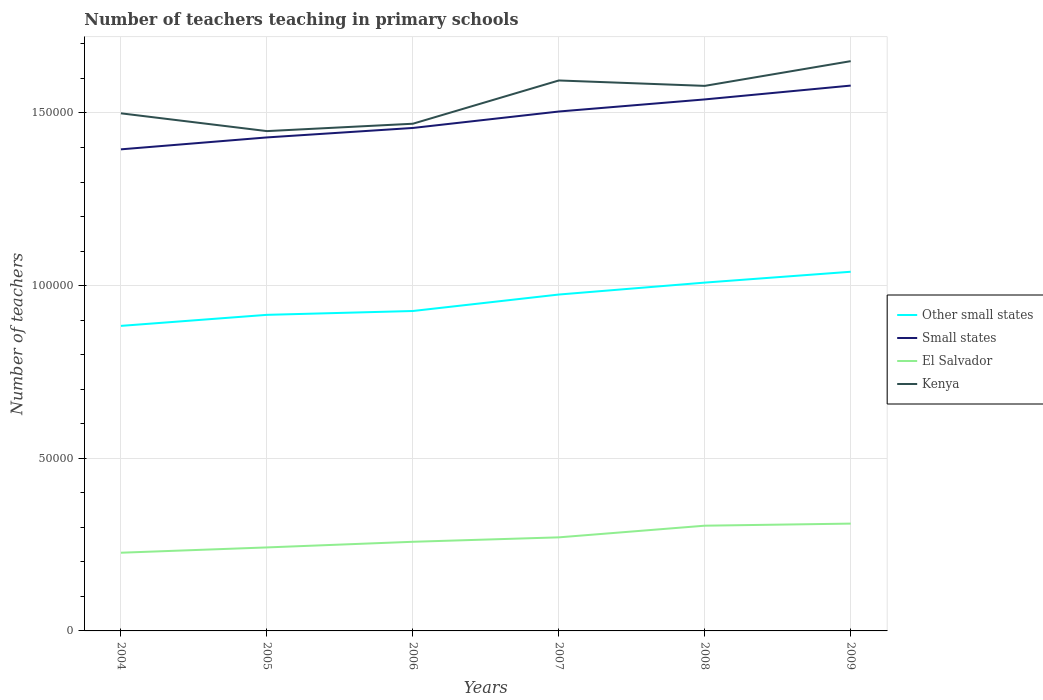Does the line corresponding to El Salvador intersect with the line corresponding to Other small states?
Offer a terse response. No. Across all years, what is the maximum number of teachers teaching in primary schools in Small states?
Provide a succinct answer. 1.39e+05. What is the total number of teachers teaching in primary schools in El Salvador in the graph?
Offer a very short reply. -8428. What is the difference between the highest and the second highest number of teachers teaching in primary schools in El Salvador?
Your response must be concise. 8428. How many lines are there?
Provide a succinct answer. 4. Are the values on the major ticks of Y-axis written in scientific E-notation?
Your answer should be very brief. No. Does the graph contain any zero values?
Offer a very short reply. No. Where does the legend appear in the graph?
Your answer should be compact. Center right. How many legend labels are there?
Give a very brief answer. 4. What is the title of the graph?
Provide a succinct answer. Number of teachers teaching in primary schools. Does "Greenland" appear as one of the legend labels in the graph?
Your answer should be compact. No. What is the label or title of the X-axis?
Keep it short and to the point. Years. What is the label or title of the Y-axis?
Offer a terse response. Number of teachers. What is the Number of teachers in Other small states in 2004?
Offer a terse response. 8.83e+04. What is the Number of teachers of Small states in 2004?
Provide a short and direct response. 1.39e+05. What is the Number of teachers of El Salvador in 2004?
Your response must be concise. 2.26e+04. What is the Number of teachers in Kenya in 2004?
Provide a succinct answer. 1.50e+05. What is the Number of teachers in Other small states in 2005?
Your answer should be very brief. 9.15e+04. What is the Number of teachers of Small states in 2005?
Give a very brief answer. 1.43e+05. What is the Number of teachers in El Salvador in 2005?
Give a very brief answer. 2.42e+04. What is the Number of teachers of Kenya in 2005?
Your answer should be very brief. 1.45e+05. What is the Number of teachers of Other small states in 2006?
Keep it short and to the point. 9.26e+04. What is the Number of teachers in Small states in 2006?
Offer a terse response. 1.46e+05. What is the Number of teachers of El Salvador in 2006?
Your answer should be very brief. 2.58e+04. What is the Number of teachers of Kenya in 2006?
Provide a succinct answer. 1.47e+05. What is the Number of teachers of Other small states in 2007?
Provide a succinct answer. 9.74e+04. What is the Number of teachers of Small states in 2007?
Keep it short and to the point. 1.50e+05. What is the Number of teachers in El Salvador in 2007?
Offer a very short reply. 2.71e+04. What is the Number of teachers in Kenya in 2007?
Provide a short and direct response. 1.59e+05. What is the Number of teachers of Other small states in 2008?
Provide a succinct answer. 1.01e+05. What is the Number of teachers of Small states in 2008?
Your response must be concise. 1.54e+05. What is the Number of teachers in El Salvador in 2008?
Offer a very short reply. 3.05e+04. What is the Number of teachers of Kenya in 2008?
Give a very brief answer. 1.58e+05. What is the Number of teachers of Other small states in 2009?
Give a very brief answer. 1.04e+05. What is the Number of teachers of Small states in 2009?
Your answer should be very brief. 1.58e+05. What is the Number of teachers in El Salvador in 2009?
Keep it short and to the point. 3.11e+04. What is the Number of teachers of Kenya in 2009?
Keep it short and to the point. 1.65e+05. Across all years, what is the maximum Number of teachers of Other small states?
Give a very brief answer. 1.04e+05. Across all years, what is the maximum Number of teachers in Small states?
Your response must be concise. 1.58e+05. Across all years, what is the maximum Number of teachers of El Salvador?
Offer a terse response. 3.11e+04. Across all years, what is the maximum Number of teachers in Kenya?
Make the answer very short. 1.65e+05. Across all years, what is the minimum Number of teachers in Other small states?
Keep it short and to the point. 8.83e+04. Across all years, what is the minimum Number of teachers in Small states?
Give a very brief answer. 1.39e+05. Across all years, what is the minimum Number of teachers in El Salvador?
Offer a very short reply. 2.26e+04. Across all years, what is the minimum Number of teachers in Kenya?
Offer a very short reply. 1.45e+05. What is the total Number of teachers in Other small states in the graph?
Your answer should be compact. 5.75e+05. What is the total Number of teachers of Small states in the graph?
Ensure brevity in your answer.  8.90e+05. What is the total Number of teachers in El Salvador in the graph?
Your answer should be very brief. 1.61e+05. What is the total Number of teachers in Kenya in the graph?
Provide a succinct answer. 9.24e+05. What is the difference between the Number of teachers of Other small states in 2004 and that in 2005?
Ensure brevity in your answer.  -3195.5. What is the difference between the Number of teachers in Small states in 2004 and that in 2005?
Your response must be concise. -3449.75. What is the difference between the Number of teachers of El Salvador in 2004 and that in 2005?
Give a very brief answer. -1530. What is the difference between the Number of teachers in Kenya in 2004 and that in 2005?
Offer a terse response. 5149. What is the difference between the Number of teachers in Other small states in 2004 and that in 2006?
Your response must be concise. -4307.96. What is the difference between the Number of teachers in Small states in 2004 and that in 2006?
Make the answer very short. -6191.81. What is the difference between the Number of teachers in El Salvador in 2004 and that in 2006?
Your response must be concise. -3164. What is the difference between the Number of teachers in Kenya in 2004 and that in 2006?
Your answer should be compact. 3014. What is the difference between the Number of teachers of Other small states in 2004 and that in 2007?
Offer a terse response. -9074.27. What is the difference between the Number of teachers of Small states in 2004 and that in 2007?
Give a very brief answer. -1.10e+04. What is the difference between the Number of teachers in El Salvador in 2004 and that in 2007?
Your answer should be compact. -4449. What is the difference between the Number of teachers in Kenya in 2004 and that in 2007?
Offer a terse response. -9514. What is the difference between the Number of teachers in Other small states in 2004 and that in 2008?
Your answer should be compact. -1.25e+04. What is the difference between the Number of teachers in Small states in 2004 and that in 2008?
Give a very brief answer. -1.45e+04. What is the difference between the Number of teachers of El Salvador in 2004 and that in 2008?
Keep it short and to the point. -7825. What is the difference between the Number of teachers of Kenya in 2004 and that in 2008?
Offer a very short reply. -7950. What is the difference between the Number of teachers of Other small states in 2004 and that in 2009?
Your response must be concise. -1.57e+04. What is the difference between the Number of teachers of Small states in 2004 and that in 2009?
Provide a succinct answer. -1.85e+04. What is the difference between the Number of teachers in El Salvador in 2004 and that in 2009?
Ensure brevity in your answer.  -8428. What is the difference between the Number of teachers of Kenya in 2004 and that in 2009?
Give a very brief answer. -1.51e+04. What is the difference between the Number of teachers of Other small states in 2005 and that in 2006?
Your response must be concise. -1112.46. What is the difference between the Number of teachers of Small states in 2005 and that in 2006?
Provide a succinct answer. -2742.06. What is the difference between the Number of teachers of El Salvador in 2005 and that in 2006?
Offer a very short reply. -1634. What is the difference between the Number of teachers of Kenya in 2005 and that in 2006?
Your response must be concise. -2135. What is the difference between the Number of teachers in Other small states in 2005 and that in 2007?
Make the answer very short. -5878.77. What is the difference between the Number of teachers in Small states in 2005 and that in 2007?
Ensure brevity in your answer.  -7502.22. What is the difference between the Number of teachers of El Salvador in 2005 and that in 2007?
Give a very brief answer. -2919. What is the difference between the Number of teachers in Kenya in 2005 and that in 2007?
Keep it short and to the point. -1.47e+04. What is the difference between the Number of teachers in Other small states in 2005 and that in 2008?
Make the answer very short. -9336.92. What is the difference between the Number of teachers in Small states in 2005 and that in 2008?
Make the answer very short. -1.10e+04. What is the difference between the Number of teachers in El Salvador in 2005 and that in 2008?
Provide a short and direct response. -6295. What is the difference between the Number of teachers of Kenya in 2005 and that in 2008?
Give a very brief answer. -1.31e+04. What is the difference between the Number of teachers of Other small states in 2005 and that in 2009?
Keep it short and to the point. -1.25e+04. What is the difference between the Number of teachers in Small states in 2005 and that in 2009?
Provide a short and direct response. -1.50e+04. What is the difference between the Number of teachers of El Salvador in 2005 and that in 2009?
Offer a very short reply. -6898. What is the difference between the Number of teachers of Kenya in 2005 and that in 2009?
Offer a terse response. -2.03e+04. What is the difference between the Number of teachers in Other small states in 2006 and that in 2007?
Offer a very short reply. -4766.31. What is the difference between the Number of teachers in Small states in 2006 and that in 2007?
Offer a very short reply. -4760.16. What is the difference between the Number of teachers of El Salvador in 2006 and that in 2007?
Your answer should be compact. -1285. What is the difference between the Number of teachers of Kenya in 2006 and that in 2007?
Your response must be concise. -1.25e+04. What is the difference between the Number of teachers of Other small states in 2006 and that in 2008?
Provide a short and direct response. -8224.46. What is the difference between the Number of teachers in Small states in 2006 and that in 2008?
Provide a short and direct response. -8265.47. What is the difference between the Number of teachers in El Salvador in 2006 and that in 2008?
Keep it short and to the point. -4661. What is the difference between the Number of teachers in Kenya in 2006 and that in 2008?
Your answer should be very brief. -1.10e+04. What is the difference between the Number of teachers in Other small states in 2006 and that in 2009?
Provide a short and direct response. -1.14e+04. What is the difference between the Number of teachers of Small states in 2006 and that in 2009?
Your answer should be compact. -1.23e+04. What is the difference between the Number of teachers in El Salvador in 2006 and that in 2009?
Provide a succinct answer. -5264. What is the difference between the Number of teachers in Kenya in 2006 and that in 2009?
Ensure brevity in your answer.  -1.81e+04. What is the difference between the Number of teachers in Other small states in 2007 and that in 2008?
Offer a very short reply. -3458.15. What is the difference between the Number of teachers of Small states in 2007 and that in 2008?
Your response must be concise. -3505.31. What is the difference between the Number of teachers of El Salvador in 2007 and that in 2008?
Provide a short and direct response. -3376. What is the difference between the Number of teachers in Kenya in 2007 and that in 2008?
Ensure brevity in your answer.  1564. What is the difference between the Number of teachers in Other small states in 2007 and that in 2009?
Give a very brief answer. -6601.63. What is the difference between the Number of teachers of Small states in 2007 and that in 2009?
Give a very brief answer. -7508.78. What is the difference between the Number of teachers of El Salvador in 2007 and that in 2009?
Keep it short and to the point. -3979. What is the difference between the Number of teachers in Kenya in 2007 and that in 2009?
Keep it short and to the point. -5595. What is the difference between the Number of teachers in Other small states in 2008 and that in 2009?
Provide a short and direct response. -3143.48. What is the difference between the Number of teachers in Small states in 2008 and that in 2009?
Offer a very short reply. -4003.47. What is the difference between the Number of teachers of El Salvador in 2008 and that in 2009?
Your answer should be very brief. -603. What is the difference between the Number of teachers of Kenya in 2008 and that in 2009?
Your answer should be compact. -7159. What is the difference between the Number of teachers of Other small states in 2004 and the Number of teachers of Small states in 2005?
Make the answer very short. -5.46e+04. What is the difference between the Number of teachers of Other small states in 2004 and the Number of teachers of El Salvador in 2005?
Provide a short and direct response. 6.42e+04. What is the difference between the Number of teachers in Other small states in 2004 and the Number of teachers in Kenya in 2005?
Make the answer very short. -5.64e+04. What is the difference between the Number of teachers in Small states in 2004 and the Number of teachers in El Salvador in 2005?
Give a very brief answer. 1.15e+05. What is the difference between the Number of teachers of Small states in 2004 and the Number of teachers of Kenya in 2005?
Ensure brevity in your answer.  -5279.61. What is the difference between the Number of teachers of El Salvador in 2004 and the Number of teachers of Kenya in 2005?
Your answer should be very brief. -1.22e+05. What is the difference between the Number of teachers of Other small states in 2004 and the Number of teachers of Small states in 2006?
Provide a succinct answer. -5.73e+04. What is the difference between the Number of teachers of Other small states in 2004 and the Number of teachers of El Salvador in 2006?
Offer a very short reply. 6.25e+04. What is the difference between the Number of teachers of Other small states in 2004 and the Number of teachers of Kenya in 2006?
Offer a terse response. -5.85e+04. What is the difference between the Number of teachers in Small states in 2004 and the Number of teachers in El Salvador in 2006?
Provide a succinct answer. 1.14e+05. What is the difference between the Number of teachers of Small states in 2004 and the Number of teachers of Kenya in 2006?
Provide a short and direct response. -7414.61. What is the difference between the Number of teachers in El Salvador in 2004 and the Number of teachers in Kenya in 2006?
Provide a short and direct response. -1.24e+05. What is the difference between the Number of teachers in Other small states in 2004 and the Number of teachers in Small states in 2007?
Your answer should be very brief. -6.21e+04. What is the difference between the Number of teachers in Other small states in 2004 and the Number of teachers in El Salvador in 2007?
Your response must be concise. 6.12e+04. What is the difference between the Number of teachers of Other small states in 2004 and the Number of teachers of Kenya in 2007?
Your response must be concise. -7.11e+04. What is the difference between the Number of teachers in Small states in 2004 and the Number of teachers in El Salvador in 2007?
Your answer should be very brief. 1.12e+05. What is the difference between the Number of teachers of Small states in 2004 and the Number of teachers of Kenya in 2007?
Provide a succinct answer. -1.99e+04. What is the difference between the Number of teachers in El Salvador in 2004 and the Number of teachers in Kenya in 2007?
Offer a terse response. -1.37e+05. What is the difference between the Number of teachers in Other small states in 2004 and the Number of teachers in Small states in 2008?
Your response must be concise. -6.56e+04. What is the difference between the Number of teachers of Other small states in 2004 and the Number of teachers of El Salvador in 2008?
Your answer should be very brief. 5.79e+04. What is the difference between the Number of teachers in Other small states in 2004 and the Number of teachers in Kenya in 2008?
Offer a terse response. -6.95e+04. What is the difference between the Number of teachers of Small states in 2004 and the Number of teachers of El Salvador in 2008?
Give a very brief answer. 1.09e+05. What is the difference between the Number of teachers in Small states in 2004 and the Number of teachers in Kenya in 2008?
Provide a short and direct response. -1.84e+04. What is the difference between the Number of teachers in El Salvador in 2004 and the Number of teachers in Kenya in 2008?
Make the answer very short. -1.35e+05. What is the difference between the Number of teachers of Other small states in 2004 and the Number of teachers of Small states in 2009?
Your answer should be compact. -6.96e+04. What is the difference between the Number of teachers of Other small states in 2004 and the Number of teachers of El Salvador in 2009?
Give a very brief answer. 5.73e+04. What is the difference between the Number of teachers in Other small states in 2004 and the Number of teachers in Kenya in 2009?
Your answer should be compact. -7.67e+04. What is the difference between the Number of teachers of Small states in 2004 and the Number of teachers of El Salvador in 2009?
Offer a terse response. 1.08e+05. What is the difference between the Number of teachers of Small states in 2004 and the Number of teachers of Kenya in 2009?
Your answer should be very brief. -2.55e+04. What is the difference between the Number of teachers in El Salvador in 2004 and the Number of teachers in Kenya in 2009?
Offer a terse response. -1.42e+05. What is the difference between the Number of teachers in Other small states in 2005 and the Number of teachers in Small states in 2006?
Ensure brevity in your answer.  -5.41e+04. What is the difference between the Number of teachers of Other small states in 2005 and the Number of teachers of El Salvador in 2006?
Make the answer very short. 6.57e+04. What is the difference between the Number of teachers of Other small states in 2005 and the Number of teachers of Kenya in 2006?
Offer a terse response. -5.53e+04. What is the difference between the Number of teachers of Small states in 2005 and the Number of teachers of El Salvador in 2006?
Offer a very short reply. 1.17e+05. What is the difference between the Number of teachers of Small states in 2005 and the Number of teachers of Kenya in 2006?
Your answer should be very brief. -3964.86. What is the difference between the Number of teachers of El Salvador in 2005 and the Number of teachers of Kenya in 2006?
Offer a terse response. -1.23e+05. What is the difference between the Number of teachers in Other small states in 2005 and the Number of teachers in Small states in 2007?
Make the answer very short. -5.89e+04. What is the difference between the Number of teachers in Other small states in 2005 and the Number of teachers in El Salvador in 2007?
Your answer should be very brief. 6.44e+04. What is the difference between the Number of teachers of Other small states in 2005 and the Number of teachers of Kenya in 2007?
Your response must be concise. -6.79e+04. What is the difference between the Number of teachers in Small states in 2005 and the Number of teachers in El Salvador in 2007?
Offer a terse response. 1.16e+05. What is the difference between the Number of teachers in Small states in 2005 and the Number of teachers in Kenya in 2007?
Offer a terse response. -1.65e+04. What is the difference between the Number of teachers of El Salvador in 2005 and the Number of teachers of Kenya in 2007?
Make the answer very short. -1.35e+05. What is the difference between the Number of teachers of Other small states in 2005 and the Number of teachers of Small states in 2008?
Your answer should be compact. -6.24e+04. What is the difference between the Number of teachers of Other small states in 2005 and the Number of teachers of El Salvador in 2008?
Give a very brief answer. 6.11e+04. What is the difference between the Number of teachers in Other small states in 2005 and the Number of teachers in Kenya in 2008?
Make the answer very short. -6.63e+04. What is the difference between the Number of teachers in Small states in 2005 and the Number of teachers in El Salvador in 2008?
Make the answer very short. 1.12e+05. What is the difference between the Number of teachers in Small states in 2005 and the Number of teachers in Kenya in 2008?
Your answer should be compact. -1.49e+04. What is the difference between the Number of teachers in El Salvador in 2005 and the Number of teachers in Kenya in 2008?
Make the answer very short. -1.34e+05. What is the difference between the Number of teachers in Other small states in 2005 and the Number of teachers in Small states in 2009?
Keep it short and to the point. -6.64e+04. What is the difference between the Number of teachers in Other small states in 2005 and the Number of teachers in El Salvador in 2009?
Your answer should be compact. 6.05e+04. What is the difference between the Number of teachers in Other small states in 2005 and the Number of teachers in Kenya in 2009?
Offer a terse response. -7.35e+04. What is the difference between the Number of teachers of Small states in 2005 and the Number of teachers of El Salvador in 2009?
Offer a terse response. 1.12e+05. What is the difference between the Number of teachers in Small states in 2005 and the Number of teachers in Kenya in 2009?
Offer a terse response. -2.21e+04. What is the difference between the Number of teachers of El Salvador in 2005 and the Number of teachers of Kenya in 2009?
Give a very brief answer. -1.41e+05. What is the difference between the Number of teachers in Other small states in 2006 and the Number of teachers in Small states in 2007?
Your answer should be compact. -5.78e+04. What is the difference between the Number of teachers of Other small states in 2006 and the Number of teachers of El Salvador in 2007?
Offer a very short reply. 6.55e+04. What is the difference between the Number of teachers in Other small states in 2006 and the Number of teachers in Kenya in 2007?
Provide a succinct answer. -6.68e+04. What is the difference between the Number of teachers in Small states in 2006 and the Number of teachers in El Salvador in 2007?
Offer a very short reply. 1.19e+05. What is the difference between the Number of teachers of Small states in 2006 and the Number of teachers of Kenya in 2007?
Offer a terse response. -1.38e+04. What is the difference between the Number of teachers in El Salvador in 2006 and the Number of teachers in Kenya in 2007?
Offer a terse response. -1.34e+05. What is the difference between the Number of teachers in Other small states in 2006 and the Number of teachers in Small states in 2008?
Keep it short and to the point. -6.13e+04. What is the difference between the Number of teachers in Other small states in 2006 and the Number of teachers in El Salvador in 2008?
Offer a terse response. 6.22e+04. What is the difference between the Number of teachers in Other small states in 2006 and the Number of teachers in Kenya in 2008?
Offer a very short reply. -6.52e+04. What is the difference between the Number of teachers of Small states in 2006 and the Number of teachers of El Salvador in 2008?
Give a very brief answer. 1.15e+05. What is the difference between the Number of teachers in Small states in 2006 and the Number of teachers in Kenya in 2008?
Ensure brevity in your answer.  -1.22e+04. What is the difference between the Number of teachers of El Salvador in 2006 and the Number of teachers of Kenya in 2008?
Your answer should be very brief. -1.32e+05. What is the difference between the Number of teachers of Other small states in 2006 and the Number of teachers of Small states in 2009?
Your answer should be compact. -6.53e+04. What is the difference between the Number of teachers of Other small states in 2006 and the Number of teachers of El Salvador in 2009?
Provide a succinct answer. 6.16e+04. What is the difference between the Number of teachers of Other small states in 2006 and the Number of teachers of Kenya in 2009?
Provide a succinct answer. -7.24e+04. What is the difference between the Number of teachers in Small states in 2006 and the Number of teachers in El Salvador in 2009?
Keep it short and to the point. 1.15e+05. What is the difference between the Number of teachers in Small states in 2006 and the Number of teachers in Kenya in 2009?
Your response must be concise. -1.93e+04. What is the difference between the Number of teachers of El Salvador in 2006 and the Number of teachers of Kenya in 2009?
Ensure brevity in your answer.  -1.39e+05. What is the difference between the Number of teachers of Other small states in 2007 and the Number of teachers of Small states in 2008?
Offer a very short reply. -5.65e+04. What is the difference between the Number of teachers in Other small states in 2007 and the Number of teachers in El Salvador in 2008?
Make the answer very short. 6.69e+04. What is the difference between the Number of teachers of Other small states in 2007 and the Number of teachers of Kenya in 2008?
Offer a terse response. -6.04e+04. What is the difference between the Number of teachers of Small states in 2007 and the Number of teachers of El Salvador in 2008?
Provide a short and direct response. 1.20e+05. What is the difference between the Number of teachers in Small states in 2007 and the Number of teachers in Kenya in 2008?
Your response must be concise. -7426.64. What is the difference between the Number of teachers in El Salvador in 2007 and the Number of teachers in Kenya in 2008?
Your answer should be very brief. -1.31e+05. What is the difference between the Number of teachers of Other small states in 2007 and the Number of teachers of Small states in 2009?
Make the answer very short. -6.05e+04. What is the difference between the Number of teachers in Other small states in 2007 and the Number of teachers in El Salvador in 2009?
Your response must be concise. 6.63e+04. What is the difference between the Number of teachers in Other small states in 2007 and the Number of teachers in Kenya in 2009?
Your answer should be very brief. -6.76e+04. What is the difference between the Number of teachers in Small states in 2007 and the Number of teachers in El Salvador in 2009?
Keep it short and to the point. 1.19e+05. What is the difference between the Number of teachers in Small states in 2007 and the Number of teachers in Kenya in 2009?
Provide a short and direct response. -1.46e+04. What is the difference between the Number of teachers in El Salvador in 2007 and the Number of teachers in Kenya in 2009?
Your answer should be very brief. -1.38e+05. What is the difference between the Number of teachers of Other small states in 2008 and the Number of teachers of Small states in 2009?
Ensure brevity in your answer.  -5.71e+04. What is the difference between the Number of teachers of Other small states in 2008 and the Number of teachers of El Salvador in 2009?
Offer a very short reply. 6.98e+04. What is the difference between the Number of teachers in Other small states in 2008 and the Number of teachers in Kenya in 2009?
Give a very brief answer. -6.41e+04. What is the difference between the Number of teachers in Small states in 2008 and the Number of teachers in El Salvador in 2009?
Your answer should be compact. 1.23e+05. What is the difference between the Number of teachers of Small states in 2008 and the Number of teachers of Kenya in 2009?
Offer a very short reply. -1.11e+04. What is the difference between the Number of teachers in El Salvador in 2008 and the Number of teachers in Kenya in 2009?
Make the answer very short. -1.35e+05. What is the average Number of teachers in Other small states per year?
Offer a very short reply. 9.58e+04. What is the average Number of teachers of Small states per year?
Offer a terse response. 1.48e+05. What is the average Number of teachers in El Salvador per year?
Your response must be concise. 2.69e+04. What is the average Number of teachers of Kenya per year?
Offer a very short reply. 1.54e+05. In the year 2004, what is the difference between the Number of teachers of Other small states and Number of teachers of Small states?
Your response must be concise. -5.11e+04. In the year 2004, what is the difference between the Number of teachers in Other small states and Number of teachers in El Salvador?
Provide a succinct answer. 6.57e+04. In the year 2004, what is the difference between the Number of teachers of Other small states and Number of teachers of Kenya?
Your answer should be compact. -6.16e+04. In the year 2004, what is the difference between the Number of teachers of Small states and Number of teachers of El Salvador?
Give a very brief answer. 1.17e+05. In the year 2004, what is the difference between the Number of teachers in Small states and Number of teachers in Kenya?
Offer a very short reply. -1.04e+04. In the year 2004, what is the difference between the Number of teachers in El Salvador and Number of teachers in Kenya?
Ensure brevity in your answer.  -1.27e+05. In the year 2005, what is the difference between the Number of teachers of Other small states and Number of teachers of Small states?
Provide a short and direct response. -5.14e+04. In the year 2005, what is the difference between the Number of teachers in Other small states and Number of teachers in El Salvador?
Your response must be concise. 6.74e+04. In the year 2005, what is the difference between the Number of teachers of Other small states and Number of teachers of Kenya?
Your answer should be very brief. -5.32e+04. In the year 2005, what is the difference between the Number of teachers of Small states and Number of teachers of El Salvador?
Give a very brief answer. 1.19e+05. In the year 2005, what is the difference between the Number of teachers in Small states and Number of teachers in Kenya?
Provide a short and direct response. -1829.86. In the year 2005, what is the difference between the Number of teachers of El Salvador and Number of teachers of Kenya?
Offer a terse response. -1.21e+05. In the year 2006, what is the difference between the Number of teachers in Other small states and Number of teachers in Small states?
Make the answer very short. -5.30e+04. In the year 2006, what is the difference between the Number of teachers in Other small states and Number of teachers in El Salvador?
Offer a very short reply. 6.68e+04. In the year 2006, what is the difference between the Number of teachers of Other small states and Number of teachers of Kenya?
Keep it short and to the point. -5.42e+04. In the year 2006, what is the difference between the Number of teachers of Small states and Number of teachers of El Salvador?
Keep it short and to the point. 1.20e+05. In the year 2006, what is the difference between the Number of teachers in Small states and Number of teachers in Kenya?
Provide a succinct answer. -1222.8. In the year 2006, what is the difference between the Number of teachers of El Salvador and Number of teachers of Kenya?
Give a very brief answer. -1.21e+05. In the year 2007, what is the difference between the Number of teachers in Other small states and Number of teachers in Small states?
Ensure brevity in your answer.  -5.30e+04. In the year 2007, what is the difference between the Number of teachers of Other small states and Number of teachers of El Salvador?
Ensure brevity in your answer.  7.03e+04. In the year 2007, what is the difference between the Number of teachers in Other small states and Number of teachers in Kenya?
Your answer should be compact. -6.20e+04. In the year 2007, what is the difference between the Number of teachers in Small states and Number of teachers in El Salvador?
Provide a short and direct response. 1.23e+05. In the year 2007, what is the difference between the Number of teachers of Small states and Number of teachers of Kenya?
Your answer should be compact. -8990.64. In the year 2007, what is the difference between the Number of teachers in El Salvador and Number of teachers in Kenya?
Offer a terse response. -1.32e+05. In the year 2008, what is the difference between the Number of teachers of Other small states and Number of teachers of Small states?
Ensure brevity in your answer.  -5.30e+04. In the year 2008, what is the difference between the Number of teachers of Other small states and Number of teachers of El Salvador?
Provide a succinct answer. 7.04e+04. In the year 2008, what is the difference between the Number of teachers in Other small states and Number of teachers in Kenya?
Your answer should be very brief. -5.70e+04. In the year 2008, what is the difference between the Number of teachers in Small states and Number of teachers in El Salvador?
Make the answer very short. 1.23e+05. In the year 2008, what is the difference between the Number of teachers in Small states and Number of teachers in Kenya?
Your answer should be compact. -3921.33. In the year 2008, what is the difference between the Number of teachers in El Salvador and Number of teachers in Kenya?
Provide a succinct answer. -1.27e+05. In the year 2009, what is the difference between the Number of teachers in Other small states and Number of teachers in Small states?
Your answer should be compact. -5.39e+04. In the year 2009, what is the difference between the Number of teachers of Other small states and Number of teachers of El Salvador?
Your answer should be compact. 7.29e+04. In the year 2009, what is the difference between the Number of teachers of Other small states and Number of teachers of Kenya?
Keep it short and to the point. -6.10e+04. In the year 2009, what is the difference between the Number of teachers in Small states and Number of teachers in El Salvador?
Give a very brief answer. 1.27e+05. In the year 2009, what is the difference between the Number of teachers in Small states and Number of teachers in Kenya?
Ensure brevity in your answer.  -7076.86. In the year 2009, what is the difference between the Number of teachers in El Salvador and Number of teachers in Kenya?
Provide a succinct answer. -1.34e+05. What is the ratio of the Number of teachers of Other small states in 2004 to that in 2005?
Provide a short and direct response. 0.97. What is the ratio of the Number of teachers in Small states in 2004 to that in 2005?
Make the answer very short. 0.98. What is the ratio of the Number of teachers of El Salvador in 2004 to that in 2005?
Offer a very short reply. 0.94. What is the ratio of the Number of teachers in Kenya in 2004 to that in 2005?
Keep it short and to the point. 1.04. What is the ratio of the Number of teachers in Other small states in 2004 to that in 2006?
Make the answer very short. 0.95. What is the ratio of the Number of teachers of Small states in 2004 to that in 2006?
Provide a short and direct response. 0.96. What is the ratio of the Number of teachers in El Salvador in 2004 to that in 2006?
Your answer should be very brief. 0.88. What is the ratio of the Number of teachers of Kenya in 2004 to that in 2006?
Make the answer very short. 1.02. What is the ratio of the Number of teachers in Other small states in 2004 to that in 2007?
Give a very brief answer. 0.91. What is the ratio of the Number of teachers of Small states in 2004 to that in 2007?
Offer a terse response. 0.93. What is the ratio of the Number of teachers of El Salvador in 2004 to that in 2007?
Keep it short and to the point. 0.84. What is the ratio of the Number of teachers in Kenya in 2004 to that in 2007?
Offer a very short reply. 0.94. What is the ratio of the Number of teachers of Other small states in 2004 to that in 2008?
Provide a short and direct response. 0.88. What is the ratio of the Number of teachers of Small states in 2004 to that in 2008?
Keep it short and to the point. 0.91. What is the ratio of the Number of teachers in El Salvador in 2004 to that in 2008?
Your answer should be compact. 0.74. What is the ratio of the Number of teachers in Kenya in 2004 to that in 2008?
Provide a succinct answer. 0.95. What is the ratio of the Number of teachers of Other small states in 2004 to that in 2009?
Your answer should be compact. 0.85. What is the ratio of the Number of teachers in Small states in 2004 to that in 2009?
Make the answer very short. 0.88. What is the ratio of the Number of teachers in El Salvador in 2004 to that in 2009?
Your answer should be compact. 0.73. What is the ratio of the Number of teachers in Kenya in 2004 to that in 2009?
Offer a very short reply. 0.91. What is the ratio of the Number of teachers of Small states in 2005 to that in 2006?
Ensure brevity in your answer.  0.98. What is the ratio of the Number of teachers of El Salvador in 2005 to that in 2006?
Your answer should be compact. 0.94. What is the ratio of the Number of teachers of Kenya in 2005 to that in 2006?
Offer a very short reply. 0.99. What is the ratio of the Number of teachers in Other small states in 2005 to that in 2007?
Keep it short and to the point. 0.94. What is the ratio of the Number of teachers of Small states in 2005 to that in 2007?
Make the answer very short. 0.95. What is the ratio of the Number of teachers of El Salvador in 2005 to that in 2007?
Your answer should be compact. 0.89. What is the ratio of the Number of teachers in Kenya in 2005 to that in 2007?
Your response must be concise. 0.91. What is the ratio of the Number of teachers of Other small states in 2005 to that in 2008?
Give a very brief answer. 0.91. What is the ratio of the Number of teachers of Small states in 2005 to that in 2008?
Offer a terse response. 0.93. What is the ratio of the Number of teachers in El Salvador in 2005 to that in 2008?
Keep it short and to the point. 0.79. What is the ratio of the Number of teachers of Kenya in 2005 to that in 2008?
Provide a succinct answer. 0.92. What is the ratio of the Number of teachers of Other small states in 2005 to that in 2009?
Your response must be concise. 0.88. What is the ratio of the Number of teachers in Small states in 2005 to that in 2009?
Your answer should be very brief. 0.9. What is the ratio of the Number of teachers of El Salvador in 2005 to that in 2009?
Your answer should be compact. 0.78. What is the ratio of the Number of teachers in Kenya in 2005 to that in 2009?
Provide a succinct answer. 0.88. What is the ratio of the Number of teachers in Other small states in 2006 to that in 2007?
Provide a short and direct response. 0.95. What is the ratio of the Number of teachers in Small states in 2006 to that in 2007?
Your response must be concise. 0.97. What is the ratio of the Number of teachers of El Salvador in 2006 to that in 2007?
Provide a succinct answer. 0.95. What is the ratio of the Number of teachers of Kenya in 2006 to that in 2007?
Provide a succinct answer. 0.92. What is the ratio of the Number of teachers in Other small states in 2006 to that in 2008?
Provide a short and direct response. 0.92. What is the ratio of the Number of teachers in Small states in 2006 to that in 2008?
Give a very brief answer. 0.95. What is the ratio of the Number of teachers in El Salvador in 2006 to that in 2008?
Your answer should be very brief. 0.85. What is the ratio of the Number of teachers of Kenya in 2006 to that in 2008?
Offer a very short reply. 0.93. What is the ratio of the Number of teachers in Other small states in 2006 to that in 2009?
Make the answer very short. 0.89. What is the ratio of the Number of teachers in Small states in 2006 to that in 2009?
Give a very brief answer. 0.92. What is the ratio of the Number of teachers in El Salvador in 2006 to that in 2009?
Provide a succinct answer. 0.83. What is the ratio of the Number of teachers of Kenya in 2006 to that in 2009?
Offer a very short reply. 0.89. What is the ratio of the Number of teachers in Other small states in 2007 to that in 2008?
Give a very brief answer. 0.97. What is the ratio of the Number of teachers of Small states in 2007 to that in 2008?
Offer a terse response. 0.98. What is the ratio of the Number of teachers in El Salvador in 2007 to that in 2008?
Keep it short and to the point. 0.89. What is the ratio of the Number of teachers in Kenya in 2007 to that in 2008?
Keep it short and to the point. 1.01. What is the ratio of the Number of teachers of Other small states in 2007 to that in 2009?
Offer a terse response. 0.94. What is the ratio of the Number of teachers of Small states in 2007 to that in 2009?
Keep it short and to the point. 0.95. What is the ratio of the Number of teachers in El Salvador in 2007 to that in 2009?
Give a very brief answer. 0.87. What is the ratio of the Number of teachers of Kenya in 2007 to that in 2009?
Give a very brief answer. 0.97. What is the ratio of the Number of teachers in Other small states in 2008 to that in 2009?
Offer a very short reply. 0.97. What is the ratio of the Number of teachers of Small states in 2008 to that in 2009?
Give a very brief answer. 0.97. What is the ratio of the Number of teachers in El Salvador in 2008 to that in 2009?
Give a very brief answer. 0.98. What is the ratio of the Number of teachers in Kenya in 2008 to that in 2009?
Provide a short and direct response. 0.96. What is the difference between the highest and the second highest Number of teachers of Other small states?
Your response must be concise. 3143.48. What is the difference between the highest and the second highest Number of teachers of Small states?
Make the answer very short. 4003.47. What is the difference between the highest and the second highest Number of teachers of El Salvador?
Your answer should be very brief. 603. What is the difference between the highest and the second highest Number of teachers in Kenya?
Provide a short and direct response. 5595. What is the difference between the highest and the lowest Number of teachers of Other small states?
Make the answer very short. 1.57e+04. What is the difference between the highest and the lowest Number of teachers of Small states?
Keep it short and to the point. 1.85e+04. What is the difference between the highest and the lowest Number of teachers of El Salvador?
Ensure brevity in your answer.  8428. What is the difference between the highest and the lowest Number of teachers in Kenya?
Your response must be concise. 2.03e+04. 